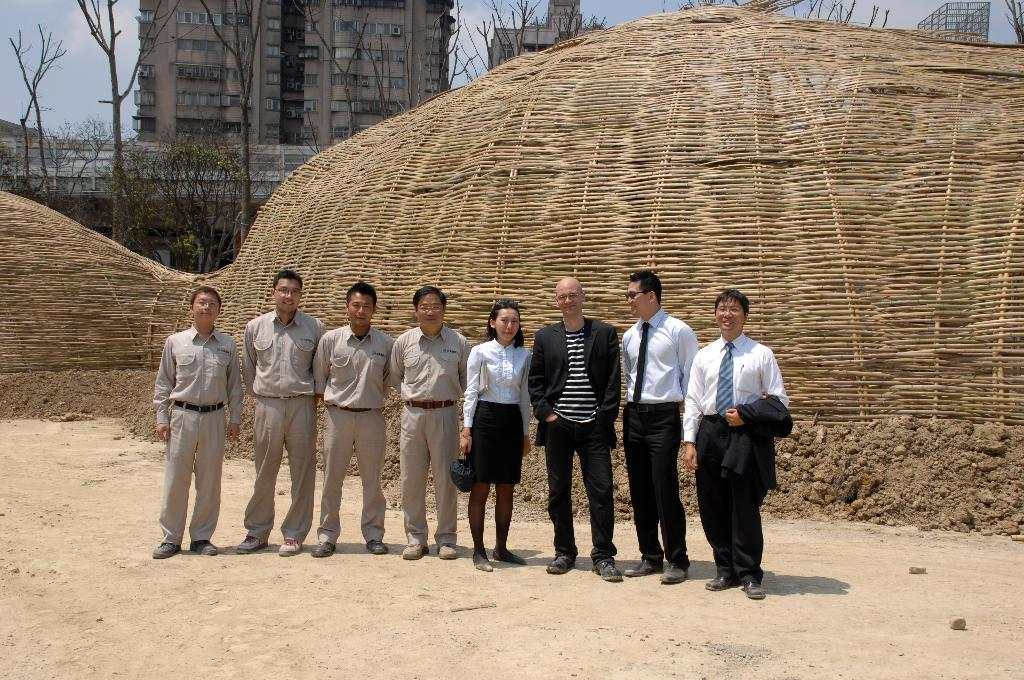What can be seen in the foreground of the picture? There are people standing in the foreground of the picture. What type of structure is visible in the image? There is a wooden structure in the image. What is the ground made of in the image? Soil is present in the image. What can be seen in the background of the image? There are trees and buildings in the background of the image. What letter does the wooden structure in the image spell out? There is no indication that the wooden structure spells out a letter in the image. Can you tell me how many times the mom appears in the image? There is no mention of a mom or any person in the image, so it cannot be determined how many times they appear. 